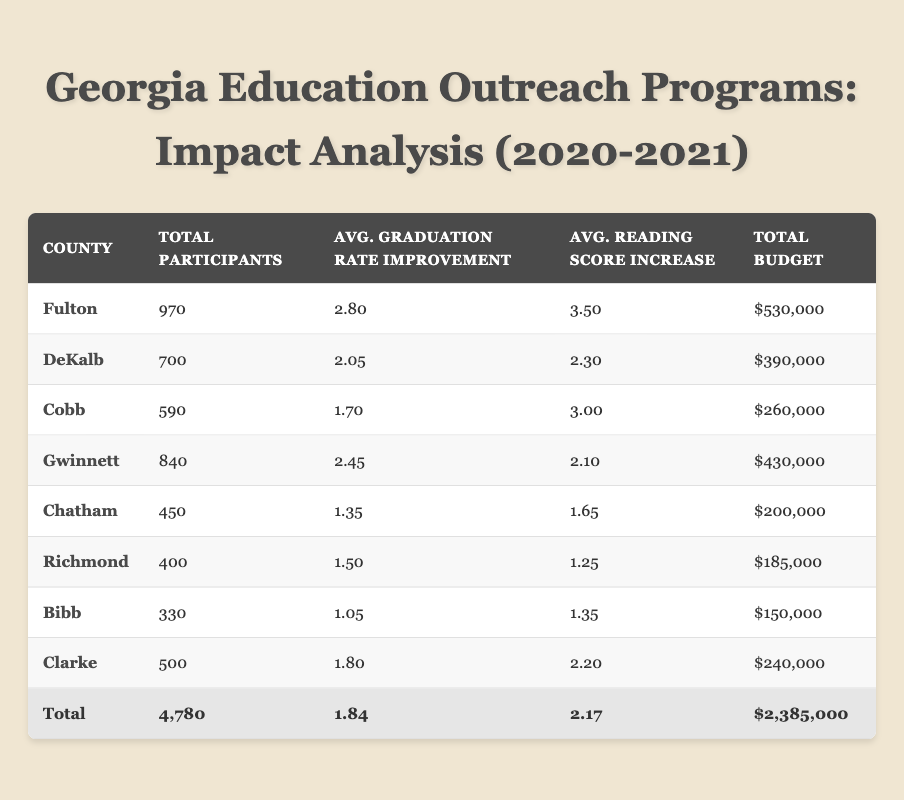What county had the highest total participants in outreach programs? The county with the highest total participants can be found in the table, which lists Fulton with a total of 970 participants.
Answer: Fulton What is the average graduation rate improvement across all counties listed? To find the average graduation rate improvement, sum all the individual improvements: (2.80 + 2.05 + 1.70 + 2.45 + 1.35 + 1.50 + 1.05 + 1.80) = 12.70. There are eight counties, so divide 12.70 by 8 to get an average of 1.5875, rounded to two decimal places is 1.59.
Answer: 1.59 Did the "Savannah Arts for All" program have an increase in reading scores in both years analyzed? Yes, in 2020 the reading score increase was 1.5 and in 2021 it was 1.8, showing an increase from one year to the next.
Answer: Yes Which program had the lowest average reading score increase? The program "Macon Music Education Initiative" in Bibb County had the lowest average reading score increases over the two years, calculated as (1.35 + 1.5)/2 = 1.425.
Answer: Macon Music Education Initiative How much was the total budget allocated to Richmond County for outreach programs? The table shows two programs for Richmond County: the first had a budget of $85,000 in 2020, and the second had a budget of $100,000 in 2021. Adding these budgets together provides a total budget of $185,000 for Richmond County.
Answer: $185,000 What was the average number of participants for the "Atlanta Youth Mentorship Initiative"? The "Atlanta Youth Mentorship Initiative" had 450 participants in 2020 and 520 in 2021. To find the average, add the two numbers together: 450 + 520 = 970. Then divide by 2, leading to an average of 485 participants.
Answer: 485 Which county had the largest increase in reading scores from 2020 to 2021? The largest increase can be calculated by comparing the reading score increases for each program from 2020 to 2021. For "Atlanta Youth Mentorship Initiative", the increase was 3.8 - 3.2 = 0.6; for "Decatur STEM Outreach", 2.5 - 2.1 = 0.4; for "Marietta Literacy Boost", 3.2 - 2.8 = 0.4; for "Lawrenceville Tech Tutors", 2.3 - 1.9 = 0.4; and for "Savannah Arts for All", 1.8 - 1.5 = 0.3. The largest increase is 0.6 from the "Atlanta Youth Mentorship Initiative".
Answer: Atlanta Youth Mentorship Initiative Was the funding source for the "Decatur STEM Outreach" program consistent over the two years? Yes, both years of the "Decatur STEM Outreach" program were funded through Corporate Sponsorship, showing consistency in funding sources.
Answer: Yes 